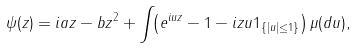Convert formula to latex. <formula><loc_0><loc_0><loc_500><loc_500>\psi ( z ) = i a z - b z ^ { 2 } + \int _ { \real } \left ( e ^ { i u z } - 1 - i z u 1 _ { \{ | u | \leq 1 \} } \right ) \mu ( d u ) ,</formula> 